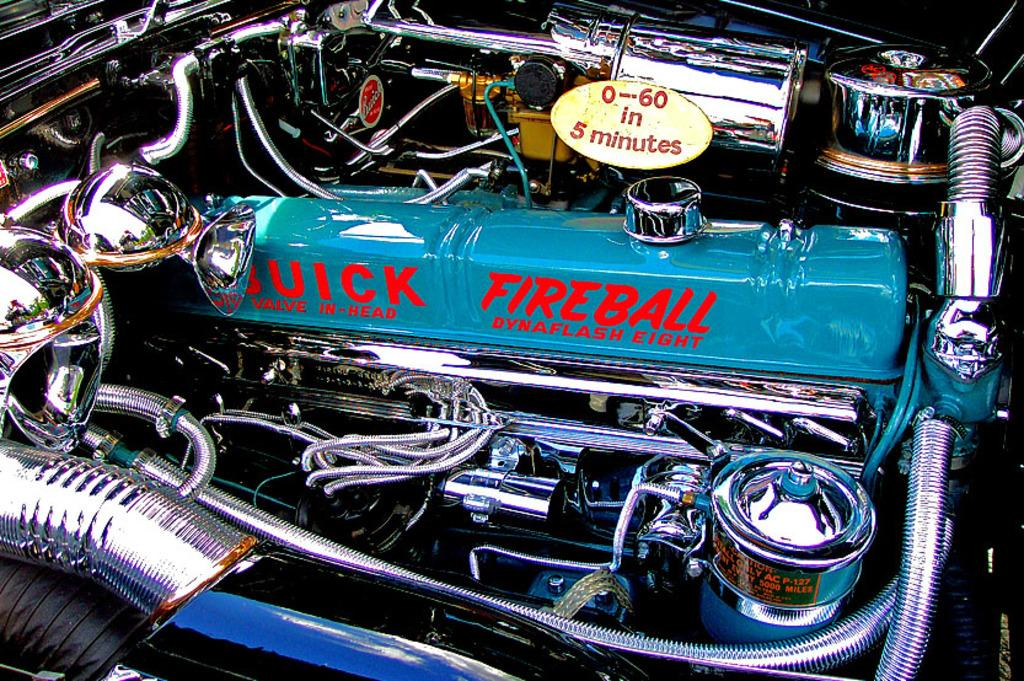What is the main subject of the image? The main subject of the image is a car engine. What type of fuel is associated with the diesel tank in the image? The diesel tank in the image is associated with diesel fuel. What are the wires in the image used for? The wires in the image are likely used for connecting and transmitting electrical signals. What are the pipes in the image used for? The pipes in the image are likely used for transporting fluids, such as oil or coolant, within the engine system. What type of insurance policy is required for the car engine in the image? The image does not provide information about insurance policies, so it cannot be determined from the image. What design elements can be seen in the car engine in the image? The image does not provide information about design elements, so it cannot be determined from the image. 